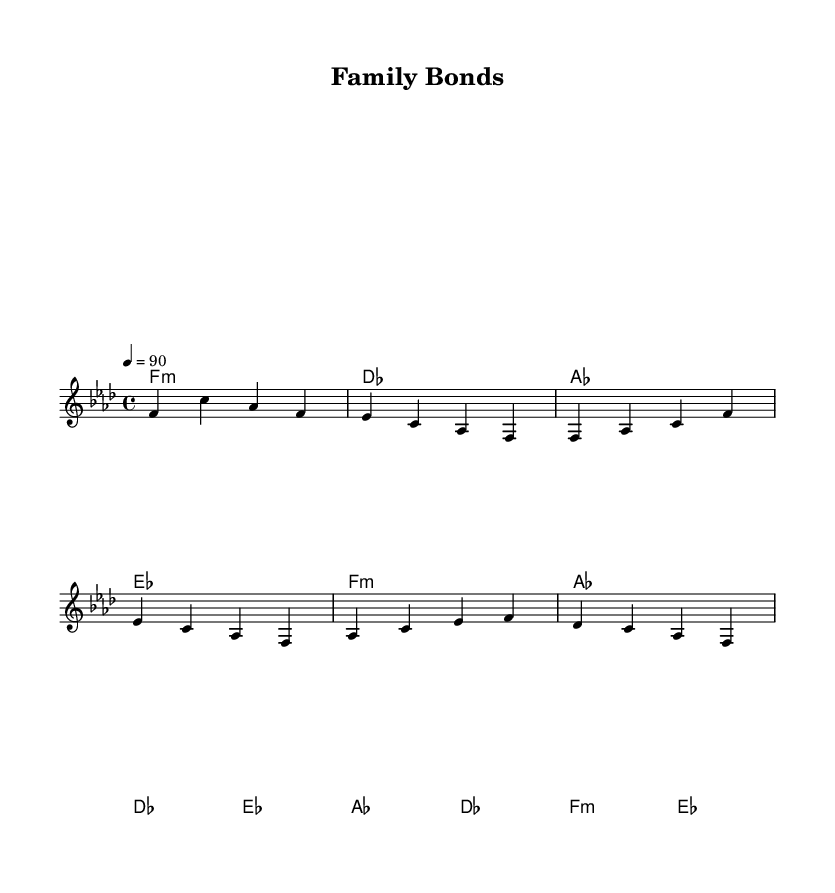What is the key signature of this music? The key signature is F minor, indicated by four flats in the key signature line at the beginning of the score.
Answer: F minor What is the time signature of this music? The time signature is 4/4, shown at the beginning of the score, indicating that there are four beats in each measure and a quarter note gets one beat.
Answer: 4/4 What is the tempo marking of this music? The tempo marking is 90 beats per minute, as indicated by the tempo notation at the beginning of the score.
Answer: 90 How many measures are in the chorus? The chorus consists of two measures, identifiable by looking at the labeled sections of the music and counting the measures between the labels.
Answer: 2 What is the chord for the bridge section? The chord for the bridge section is D flat, which appears prominently in the harmonies section during the bridge part.
Answer: D flat How does the verse relate musically to the chorus? The verse uses similar chord progressions as the chorus, but it has a different driving rhythm and structure, showing how the two sections are connected musically.
Answer: Similar chords What is the overarching theme of this rap song as reflected in the title? The title "Family Bonds" suggests a theme of overcoming challenges and strengthening relationships, which aligns with the storytelling nature typically found in rap.
Answer: Overcoming challenges 